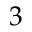<formula> <loc_0><loc_0><loc_500><loc_500>3</formula> 